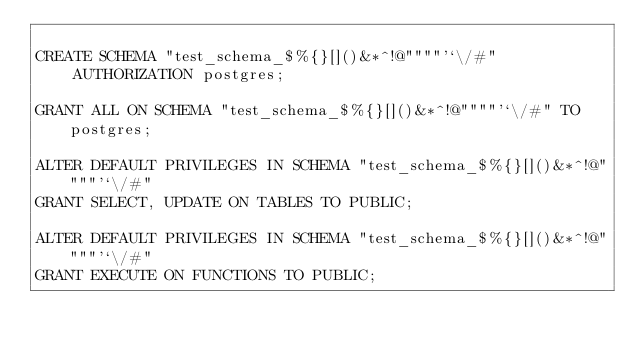Convert code to text. <code><loc_0><loc_0><loc_500><loc_500><_SQL_>
CREATE SCHEMA "test_schema_$%{}[]()&*^!@""""'`\/#"
    AUTHORIZATION postgres;

GRANT ALL ON SCHEMA "test_schema_$%{}[]()&*^!@""""'`\/#" TO postgres;

ALTER DEFAULT PRIVILEGES IN SCHEMA "test_schema_$%{}[]()&*^!@""""'`\/#"
GRANT SELECT, UPDATE ON TABLES TO PUBLIC;

ALTER DEFAULT PRIVILEGES IN SCHEMA "test_schema_$%{}[]()&*^!@""""'`\/#"
GRANT EXECUTE ON FUNCTIONS TO PUBLIC;
</code> 